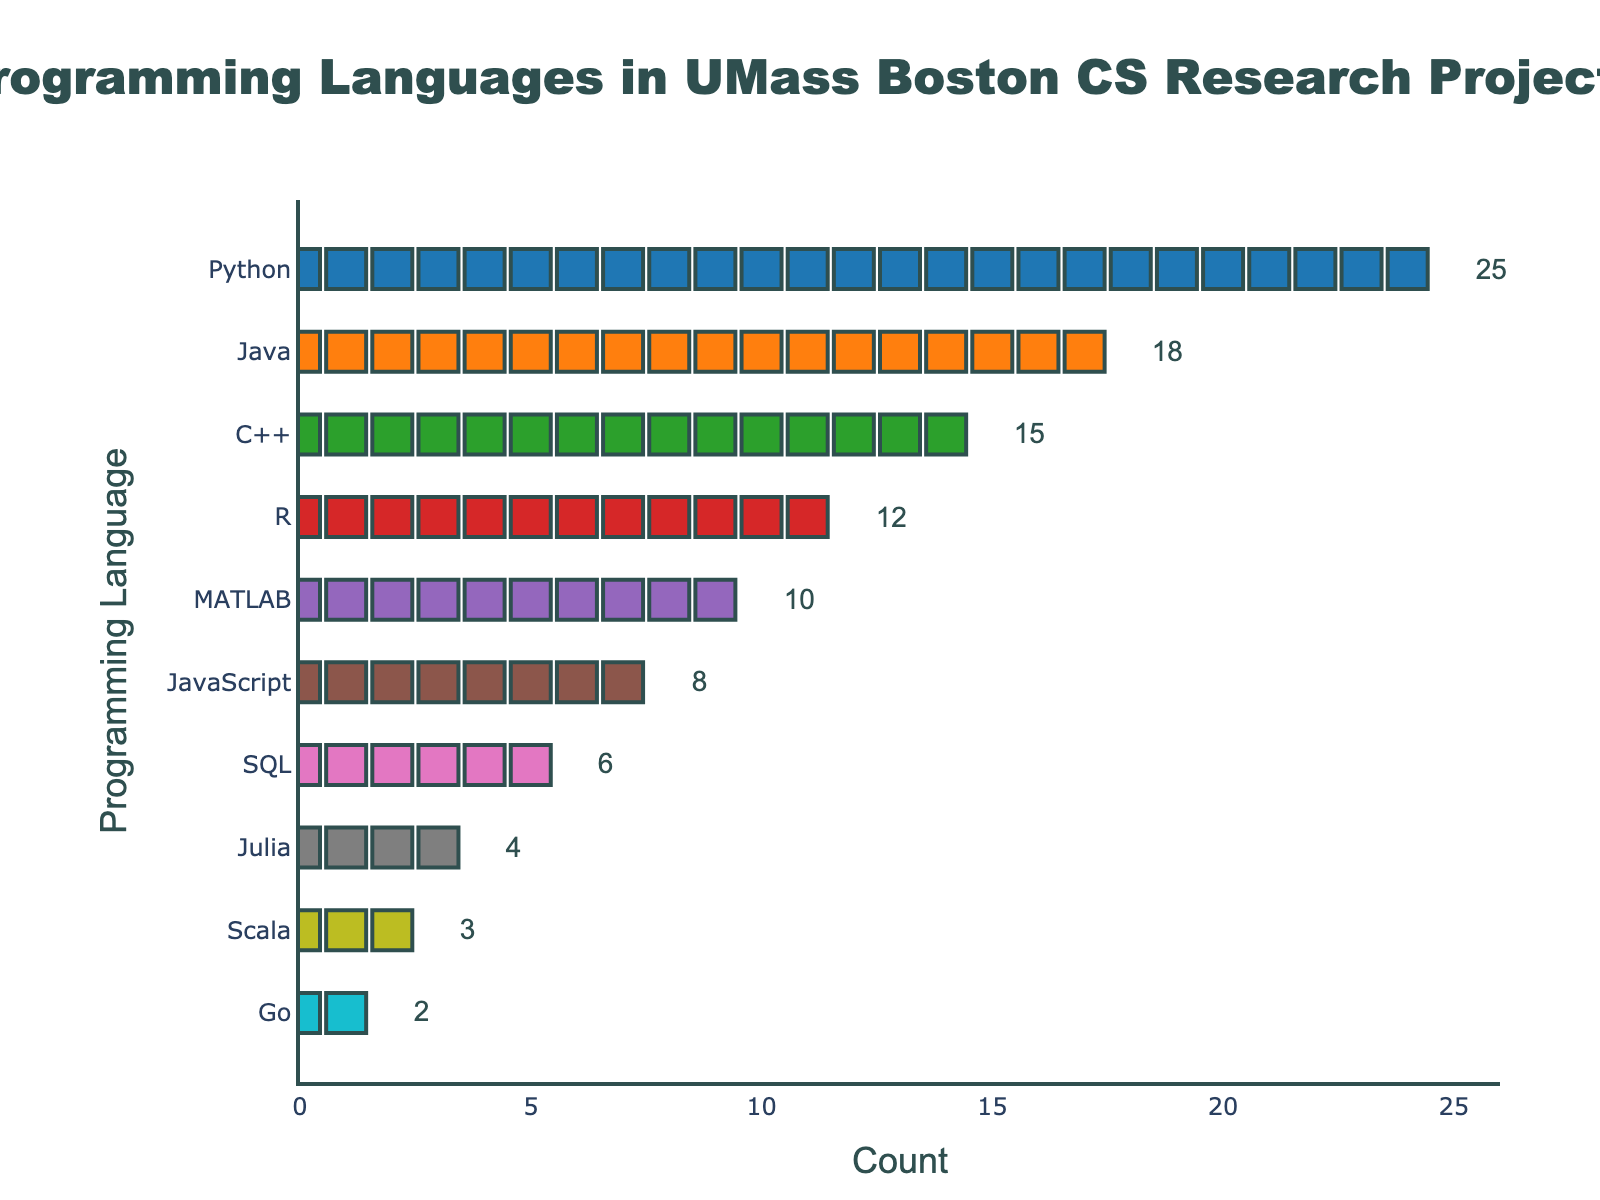What is the title of the figure? The title of the figure is located at the top of the plot. It reads: "Programming Languages in UMass Boston CS Research Projects".
Answer: "Programming Languages in UMass Boston CS Research Projects" How many programming languages are represented in the figure? Count the different categories on the y-axis. Each category represents a different programming language. There are 10 programming languages shown.
Answer: 10 Which programming language is used the most in UMass Boston CS research projects? The programming language with the longest row of markers on the x-axis is Python. Python has the highest count with 25 markers.
Answer: Python How many more research projects use Python compared to MATLAB? First, identify the counts for Python (25) and MATLAB (10). Then, subtract the count of MATLAB from Python: 25 - 10 = 15.
Answer: 15 What are the counts for Java and C++ combined? Find the counts for Java (18) and C++ (15) and then add them together: 18 + 15 = 33.
Answer: 33 Which programming language has the fewest research projects associated with it? The row with the fewest markers on the x-axis is Go, which has 2 markers.
Answer: Go Are there more research projects using JavaScript than R? Compare the count of JavaScript (8) with R (12). JavaScript has fewer projects compared to R.
Answer: No By how much does the count of R research projects exceed that of SQL research projects? Identify the counts for R (12) and SQL (6). Subtract the count of SQL from R: 12 - 6 = 6.
Answer: 6 What is the range of the counts among all programming languages represented? The highest count is for Python (25) and the lowest is for Go (2). The range is calculated as 25 - 2 = 23.
Answer: 23 How many research projects utilize languages other than Python, Java, and C++? Sum the counts of all other programming languages: R (12) + MATLAB (10) + JavaScript (8) + SQL (6) + Julia (4) + Scala (3) + Go (2) = 45.
Answer: 45 